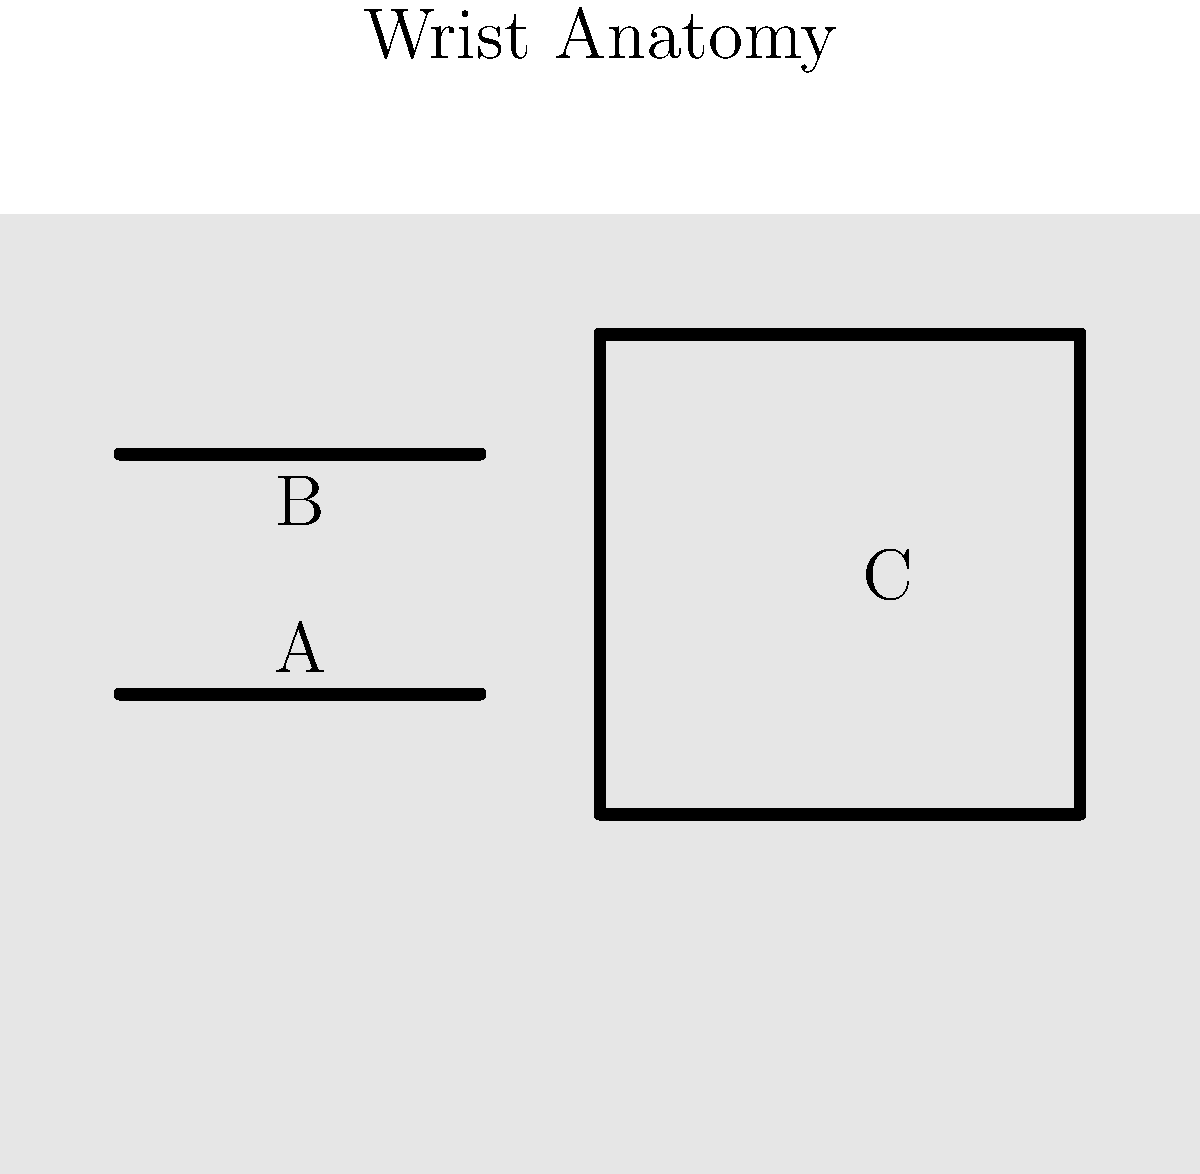In the diagram of wrist anatomy, which label (A, B, or C) corresponds to the carpal bones, a crucial area for guitarists to protect during recovery from a wrist injury? To answer this question, let's analyze the wrist anatomy diagram:

1. The diagram shows a simplified view of the wrist, with three main structures labeled A, B, and C.

2. Label A points to a long, thin bone in the upper part of the wrist. This is likely the radius, one of the two forearm bones.

3. Label B points to another long, thin bone below A. This is probably the ulna, the second forearm bone.

4. Label C points to a block-like structure in the center of the wrist. This matches the description of carpal bones.

5. Carpal bones are a group of small bones in the wrist that allow for complex movements. They are crucial for guitarists as they facilitate the fine motor skills needed for playing.

6. During recovery from a wrist injury, protecting the carpal bones is essential for guitarists to regain full range of motion and dexterity.

Therefore, the label that corresponds to the carpal bones is C.
Answer: C 